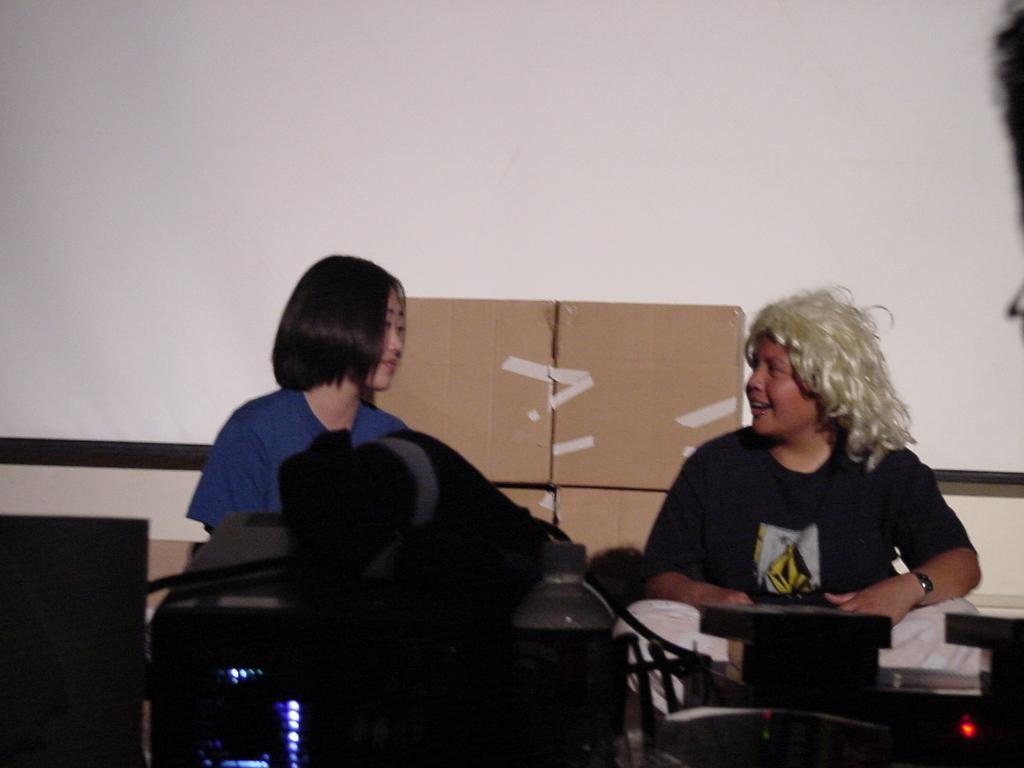How many people are in the image? There are two people in the image. What can be seen in the background of the image? There are cardboard boxes and a wall in the background of the image. What objects are in front of the people? There is a device and a bottle in front of the people, as well as other unspecified things. What type of throne is the laborer sitting on in the image? There is no laborer or throne present in the image. What is the color of the sky in the image? The sky is not visible in the image, so its color cannot be determined. 